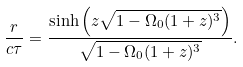<formula> <loc_0><loc_0><loc_500><loc_500>\frac { r } { c \tau } = \frac { \sinh \left ( z \sqrt { 1 - \Omega _ { 0 } ( 1 + z ) ^ { 3 } } \right ) } { \sqrt { 1 - \Omega _ { 0 } ( 1 + z ) ^ { 3 } } } .</formula> 